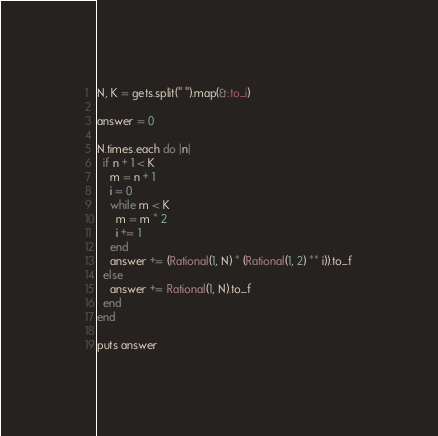Convert code to text. <code><loc_0><loc_0><loc_500><loc_500><_Ruby_>N, K = gets.split(" ").map(&:to_i)

answer = 0

N.times.each do |n|
  if n + 1 < K
    m = n + 1
    i = 0
    while m < K
      m = m * 2
      i += 1
    end
    answer += (Rational(1, N) * (Rational(1, 2) ** i)).to_f
  else
    answer += Rational(1, N).to_f
  end
end

puts answer
</code> 